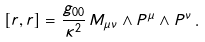Convert formula to latex. <formula><loc_0><loc_0><loc_500><loc_500>[ r , r ] = \frac { g _ { 0 0 } } { \kappa ^ { 2 } } \, M _ { \mu \nu } \wedge P ^ { \mu } \wedge P ^ { \nu } \, .</formula> 